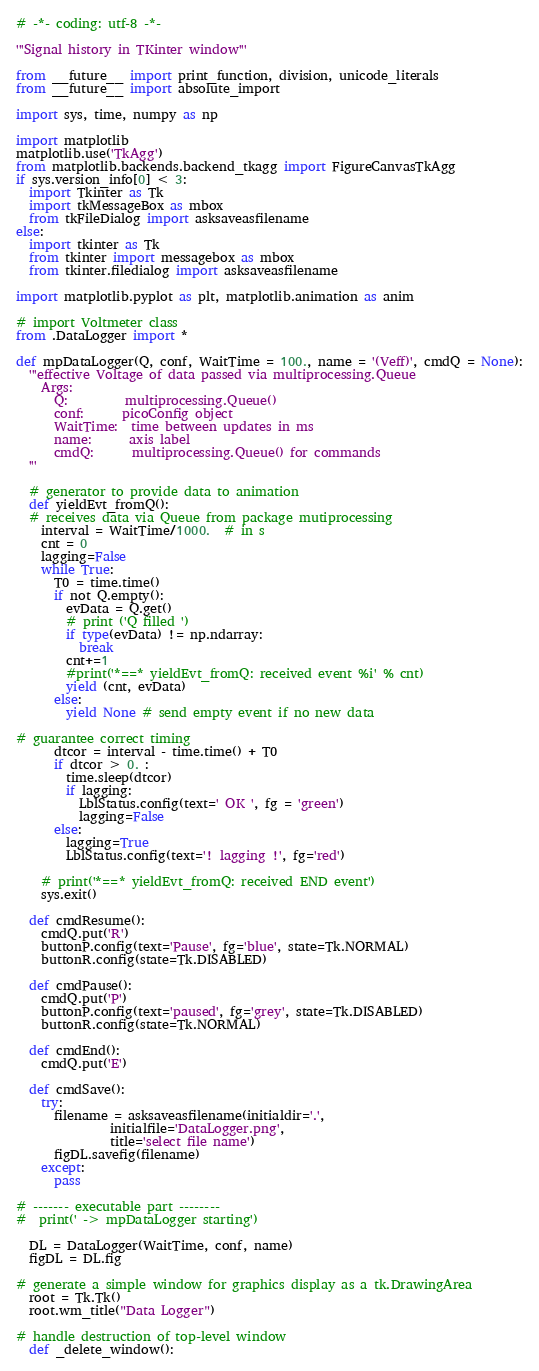Convert code to text. <code><loc_0><loc_0><loc_500><loc_500><_Python_># -*- coding: utf-8 -*-

'''Signal history in TKinter window'''

from __future__ import print_function, division, unicode_literals
from __future__ import absolute_import

import sys, time, numpy as np

import matplotlib
matplotlib.use('TkAgg')
from matplotlib.backends.backend_tkagg import FigureCanvasTkAgg
if sys.version_info[0] < 3:
  import Tkinter as Tk
  import tkMessageBox as mbox
  from tkFileDialog import asksaveasfilename
else:
  import tkinter as Tk
  from tkinter import messagebox as mbox
  from tkinter.filedialog import asksaveasfilename

import matplotlib.pyplot as plt, matplotlib.animation as anim

# import Voltmeter class
from .DataLogger import *

def mpDataLogger(Q, conf, WaitTime = 100., name = '(Veff)', cmdQ = None):
  '''effective Voltage of data passed via multiprocessing.Queue
    Args:
      Q:         multiprocessing.Queue()
      conf:      picoConfig object
      WaitTime:  time between updates in ms
      name:      axis label
      cmdQ:      multiprocessing.Queue() for commands
  '''

  # generator to provide data to animation
  def yieldEvt_fromQ():
  # receives data via Queue from package mutiprocessing
    interval = WaitTime/1000.  # in s
    cnt = 0
    lagging=False
    while True:
      T0 = time.time()
      if not Q.empty():
        evData = Q.get()
        # print ('Q filled ')
        if type(evData) != np.ndarray:
          break
        cnt+=1
        #print('*==* yieldEvt_fromQ: received event %i' % cnt)
        yield (cnt, evData)
      else:
        yield None # send empty event if no new data

# guarantee correct timing
      dtcor = interval - time.time() + T0
      if dtcor > 0. :
        time.sleep(dtcor)
        if lagging:
          LblStatus.config(text=' OK ', fg = 'green')
          lagging=False
      else:
        lagging=True
        LblStatus.config(text='! lagging !', fg='red')

    # print('*==* yieldEvt_fromQ: received END event')
    sys.exit()

  def cmdResume():
    cmdQ.put('R')
    buttonP.config(text='Pause', fg='blue', state=Tk.NORMAL)
    buttonR.config(state=Tk.DISABLED)

  def cmdPause():
    cmdQ.put('P')
    buttonP.config(text='paused', fg='grey', state=Tk.DISABLED)
    buttonR.config(state=Tk.NORMAL)

  def cmdEnd():
    cmdQ.put('E')

  def cmdSave():
    try:
      filename = asksaveasfilename(initialdir='.',
               initialfile='DataLogger.png',
               title='select file name')
      figDL.savefig(filename)
    except:
      pass

# ------- executable part --------
#  print(' -> mpDataLogger starting')

  DL = DataLogger(WaitTime, conf, name)
  figDL = DL.fig

# generate a simple window for graphics display as a tk.DrawingArea
  root = Tk.Tk()
  root.wm_title("Data Logger")

# handle destruction of top-level window
  def _delete_window():</code> 